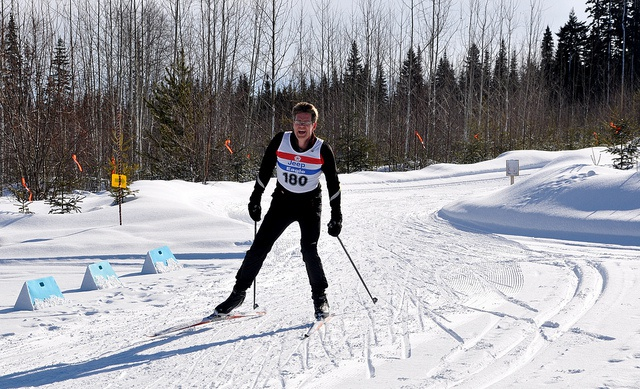Describe the objects in this image and their specific colors. I can see people in white, black, darkgray, and gray tones and skis in white, lightgray, darkgray, gray, and brown tones in this image. 